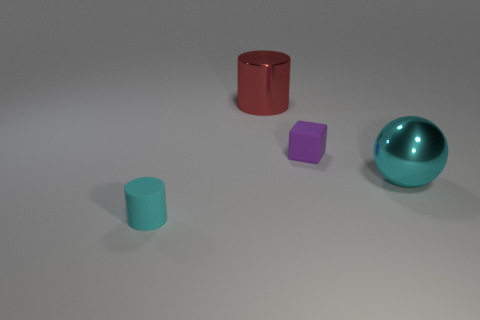Add 3 tiny rubber cubes. How many objects exist? 7 Subtract all cubes. How many objects are left? 3 Subtract all small purple objects. Subtract all large shiny balls. How many objects are left? 2 Add 2 big balls. How many big balls are left? 3 Add 1 small red rubber things. How many small red rubber things exist? 1 Subtract 0 yellow blocks. How many objects are left? 4 